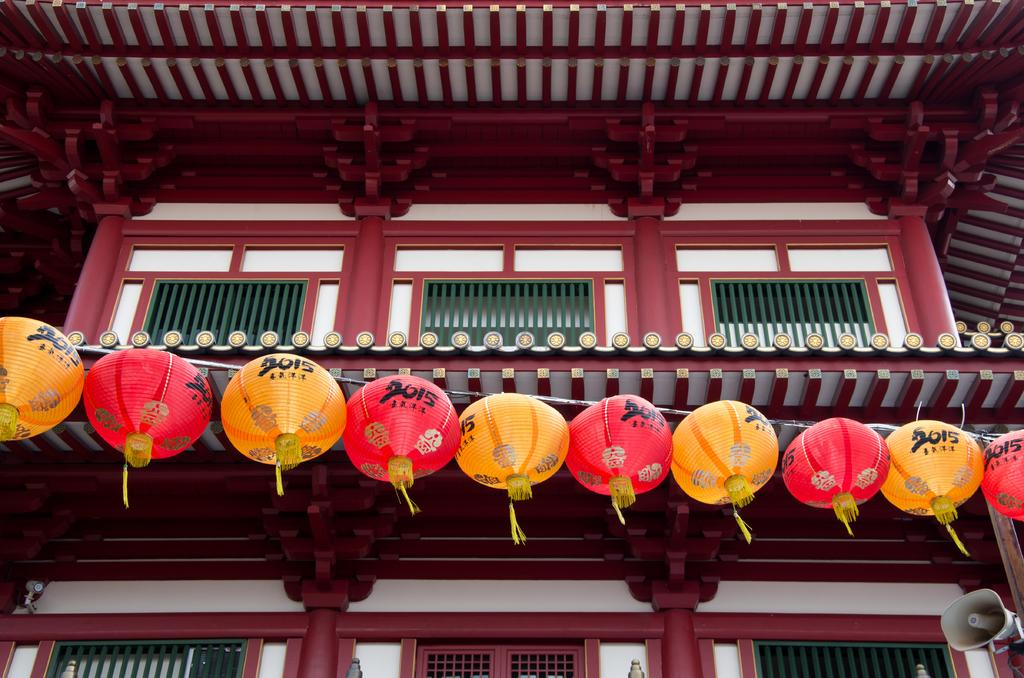<image>
Describe the image concisely. a bunch of chinese balloons hanging on a building that say 2015 on them 